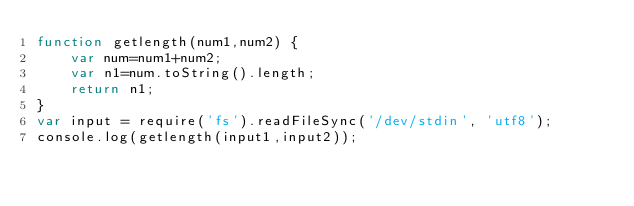Convert code to text. <code><loc_0><loc_0><loc_500><loc_500><_JavaScript_>function getlength(num1,num2) {
    var num=num1+num2;
    var n1=num.toString().length;
    return n1;
}
var input = require('fs').readFileSync('/dev/stdin', 'utf8');
console.log(getlength(input1,input2));</code> 